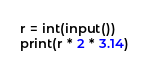<code> <loc_0><loc_0><loc_500><loc_500><_Python_>r = int(input())
print(r * 2 * 3.14)</code> 